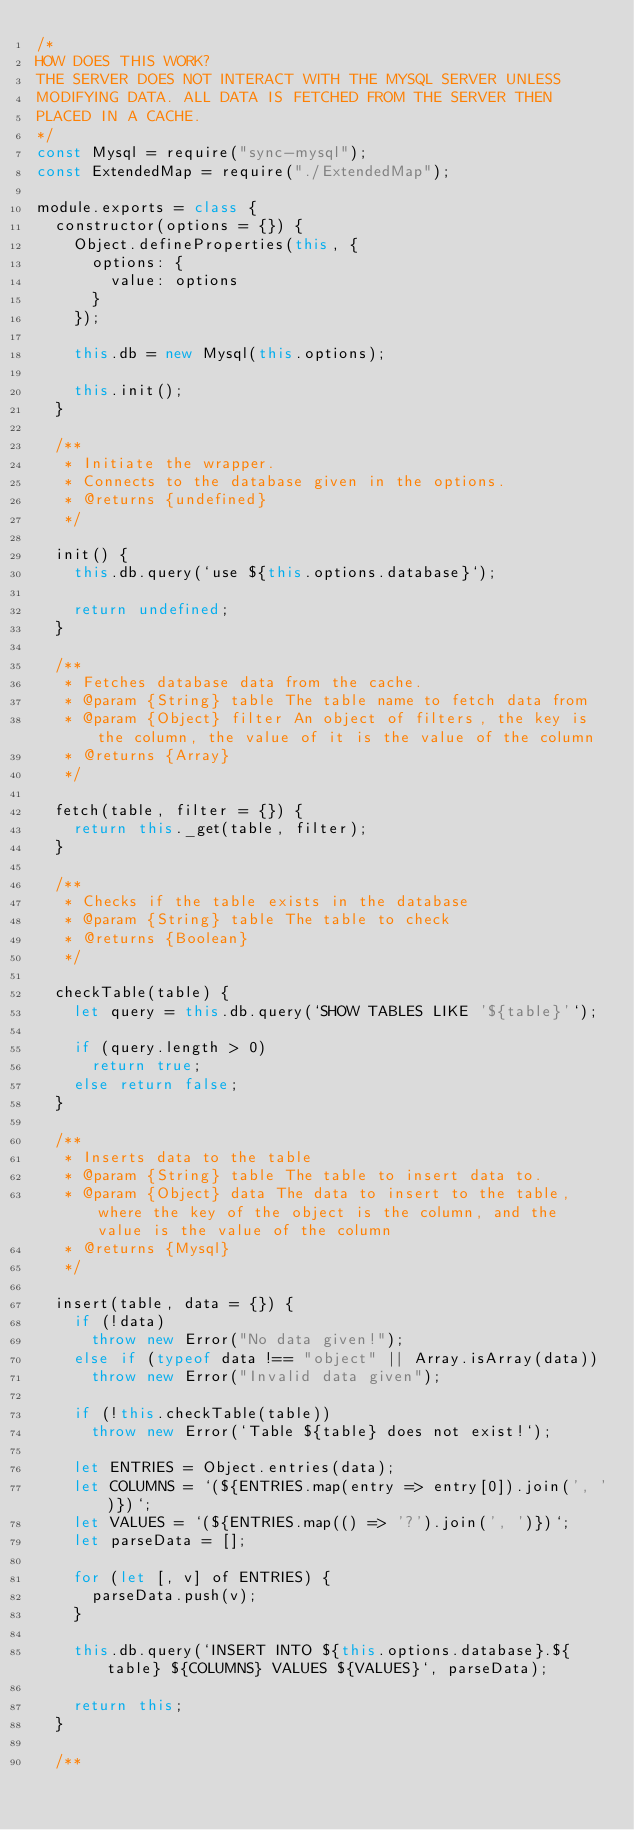Convert code to text. <code><loc_0><loc_0><loc_500><loc_500><_JavaScript_>/*
HOW DOES THIS WORK?
THE SERVER DOES NOT INTERACT WITH THE MYSQL SERVER UNLESS
MODIFYING DATA. ALL DATA IS FETCHED FROM THE SERVER THEN
PLACED IN A CACHE.
*/
const Mysql = require("sync-mysql");
const ExtendedMap = require("./ExtendedMap");

module.exports = class {
  constructor(options = {}) {
    Object.defineProperties(this, {
      options: {
        value: options
      }
    });

    this.db = new Mysql(this.options);
    
    this.init();
  }

  /**
   * Initiate the wrapper.
   * Connects to the database given in the options.
   * @returns {undefined}
   */

  init() {
    this.db.query(`use ${this.options.database}`);

    return undefined;
  }

  /**
   * Fetches database data from the cache.
   * @param {String} table The table name to fetch data from
   * @param {Object} filter An object of filters, the key is the column, the value of it is the value of the column
   * @returns {Array}
   */

  fetch(table, filter = {}) {
    return this._get(table, filter);
  }

  /**
   * Checks if the table exists in the database
   * @param {String} table The table to check
   * @returns {Boolean}
   */

  checkTable(table) {
    let query = this.db.query(`SHOW TABLES LIKE '${table}'`);

    if (query.length > 0)
      return true;
    else return false;
  }

  /**
   * Inserts data to the table
   * @param {String} table The table to insert data to.
   * @param {Object} data The data to insert to the table, where the key of the object is the column, and the value is the value of the column
   * @returns {Mysql}
   */

  insert(table, data = {}) {
    if (!data)
      throw new Error("No data given!");
    else if (typeof data !== "object" || Array.isArray(data))
      throw new Error("Invalid data given");

    if (!this.checkTable(table))
      throw new Error(`Table ${table} does not exist!`);

    let ENTRIES = Object.entries(data);
    let COLUMNS = `(${ENTRIES.map(entry => entry[0]).join(', ')})`;
    let VALUES = `(${ENTRIES.map(() => '?').join(', ')})`;
    let parseData = [];

    for (let [, v] of ENTRIES) {
      parseData.push(v);
    }

    this.db.query(`INSERT INTO ${this.options.database}.${table} ${COLUMNS} VALUES ${VALUES}`, parseData);

    return this;
  }

  /**</code> 